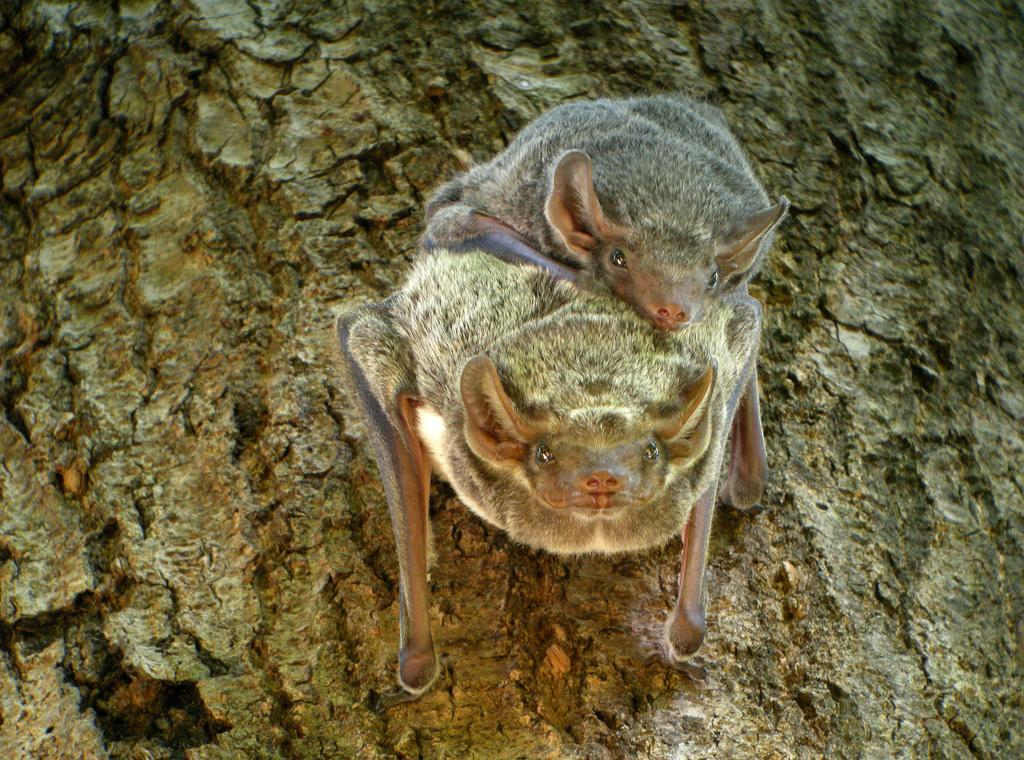What type of animals are in the image? There are two naked rumped tomb bats in the image. Where are the bats located in the image? The bats are on the surface in the image. What type of apparatus is being used by the grandmother in the image? There is no grandmother or apparatus present in the image. 